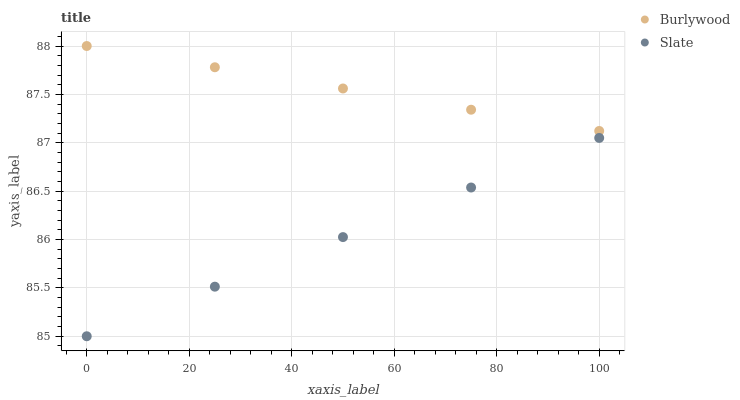Does Slate have the minimum area under the curve?
Answer yes or no. Yes. Does Burlywood have the maximum area under the curve?
Answer yes or no. Yes. Does Slate have the maximum area under the curve?
Answer yes or no. No. Is Burlywood the smoothest?
Answer yes or no. Yes. Is Slate the roughest?
Answer yes or no. Yes. Is Slate the smoothest?
Answer yes or no. No. Does Slate have the lowest value?
Answer yes or no. Yes. Does Burlywood have the highest value?
Answer yes or no. Yes. Does Slate have the highest value?
Answer yes or no. No. Is Slate less than Burlywood?
Answer yes or no. Yes. Is Burlywood greater than Slate?
Answer yes or no. Yes. Does Slate intersect Burlywood?
Answer yes or no. No. 